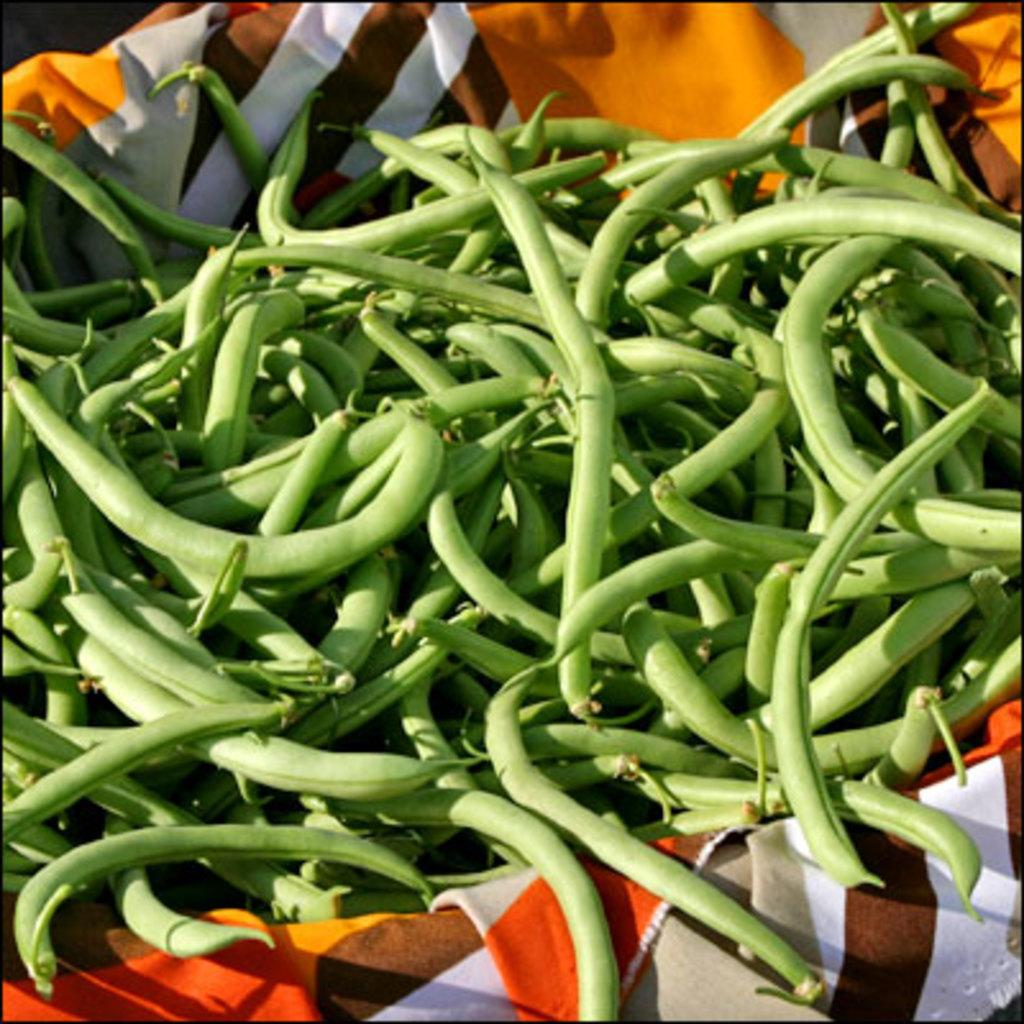What type of vegetable is present in the image? There are green beans in the image. How are the green beans contained or held in the image? The green beans are in a cloth. How do the green beans compare to the dolls in the image? There are no dolls present in the image, so a comparison cannot be made. 